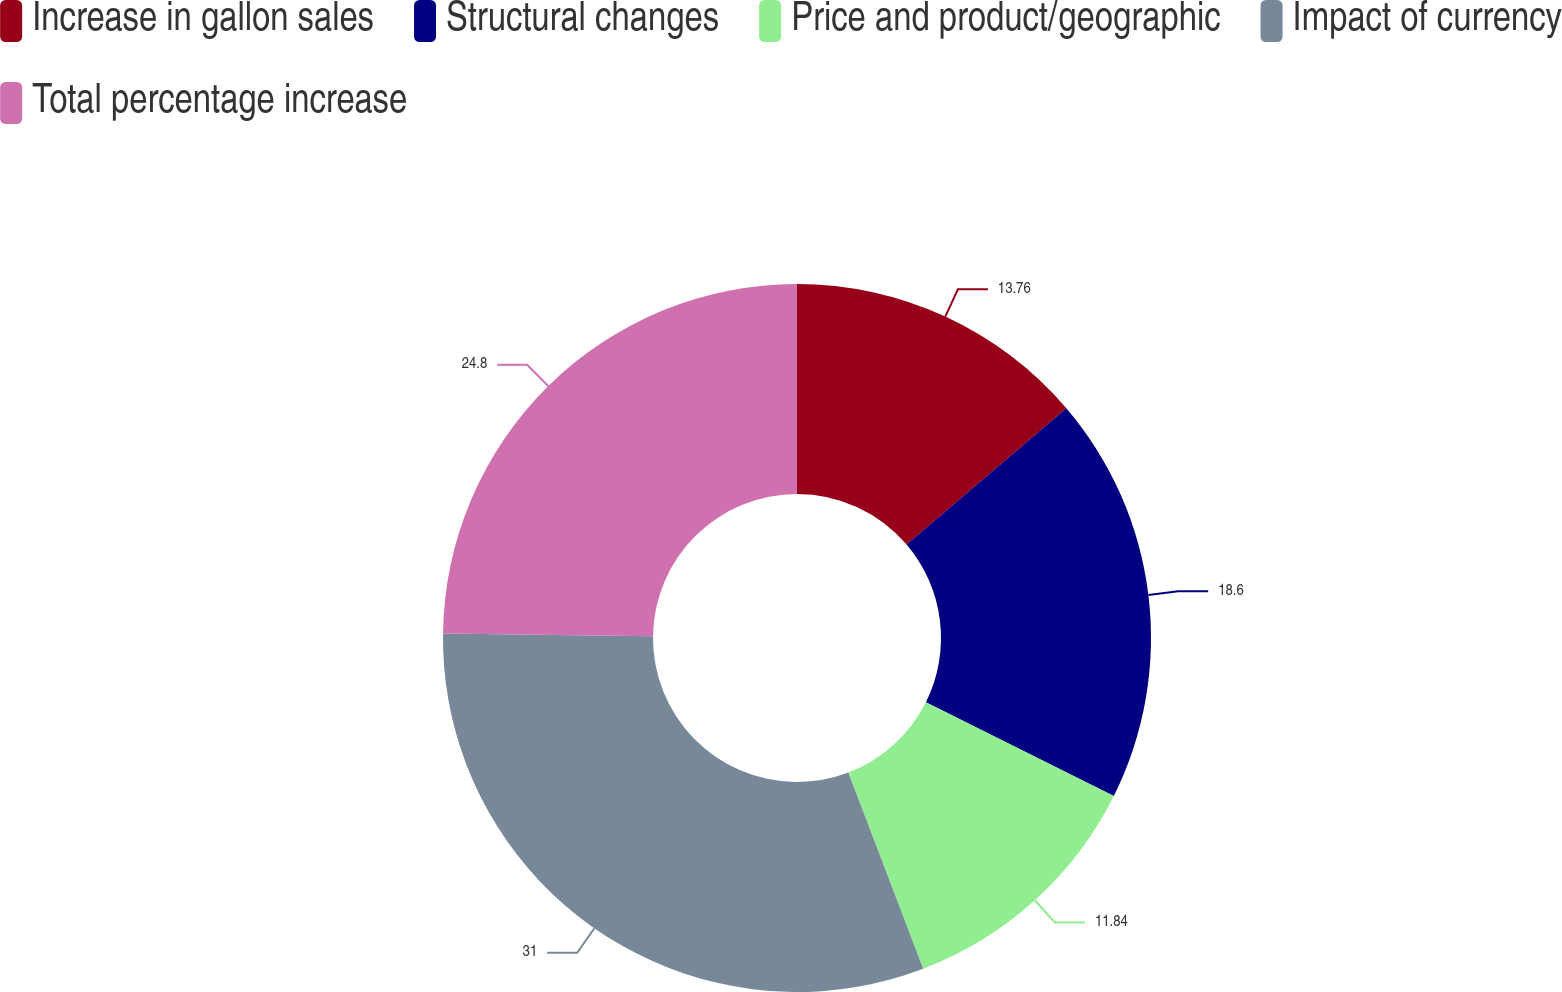Convert chart. <chart><loc_0><loc_0><loc_500><loc_500><pie_chart><fcel>Increase in gallon sales<fcel>Structural changes<fcel>Price and product/geographic<fcel>Impact of currency<fcel>Total percentage increase<nl><fcel>13.76%<fcel>18.6%<fcel>11.84%<fcel>31.0%<fcel>24.8%<nl></chart> 